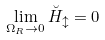Convert formula to latex. <formula><loc_0><loc_0><loc_500><loc_500>\lim _ { \Omega _ { R } \rightarrow 0 } \breve { H } _ { \updownarrow } = 0</formula> 